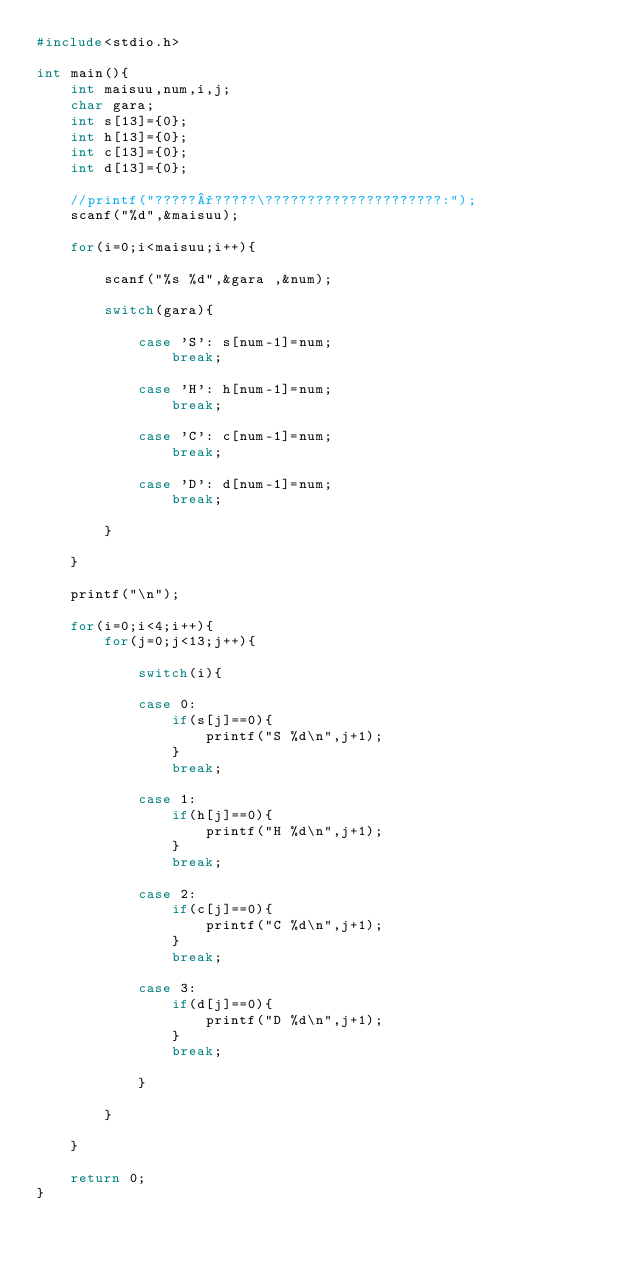Convert code to text. <code><loc_0><loc_0><loc_500><loc_500><_C_>#include<stdio.h>

int main(){
	int maisuu,num,i,j;
	char gara;
	int s[13]={0};
	int h[13]={0};
	int c[13]={0};
	int d[13]={0};
	
	//printf("?????°?????\?????????????????????:");
	scanf("%d",&maisuu);
	
	for(i=0;i<maisuu;i++){
		
		scanf("%s %d",&gara ,&num);
		
		switch(gara){
			
			case 'S': s[num-1]=num;
				break;
			
			case 'H': h[num-1]=num;
				break;
			
			case 'C': c[num-1]=num;
				break;
			
			case 'D': d[num-1]=num;
				break;
			
		}
		
	}
	
	printf("\n");
	
	for(i=0;i<4;i++){
		for(j=0;j<13;j++){
			
			switch(i){
				
			case 0: 
				if(s[j]==0){
					printf("S %d\n",j+1);
				}
				break;
			
			case 1:
				if(h[j]==0){
					printf("H %d\n",j+1);
				}
				break;
			
			case 2: 
				if(c[j]==0){
					printf("C %d\n",j+1);
				}
				break;
			
			case 3: 
				if(d[j]==0){
					printf("D %d\n",j+1);
				}
				break;
				
			}
			
		}
		
	}
	
	return 0;
}</code> 